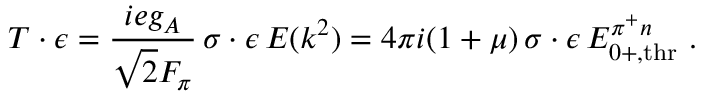<formula> <loc_0><loc_0><loc_500><loc_500>T \cdot \epsilon = \frac { i e g _ { A } } { \sqrt { 2 } F _ { \pi } } \, \sigma \cdot \epsilon \, E ( k ^ { 2 } ) = 4 \pi i ( 1 + \mu ) \, \sigma \cdot \epsilon \, E _ { 0 + , t h r } ^ { \pi ^ { + } n } .</formula> 